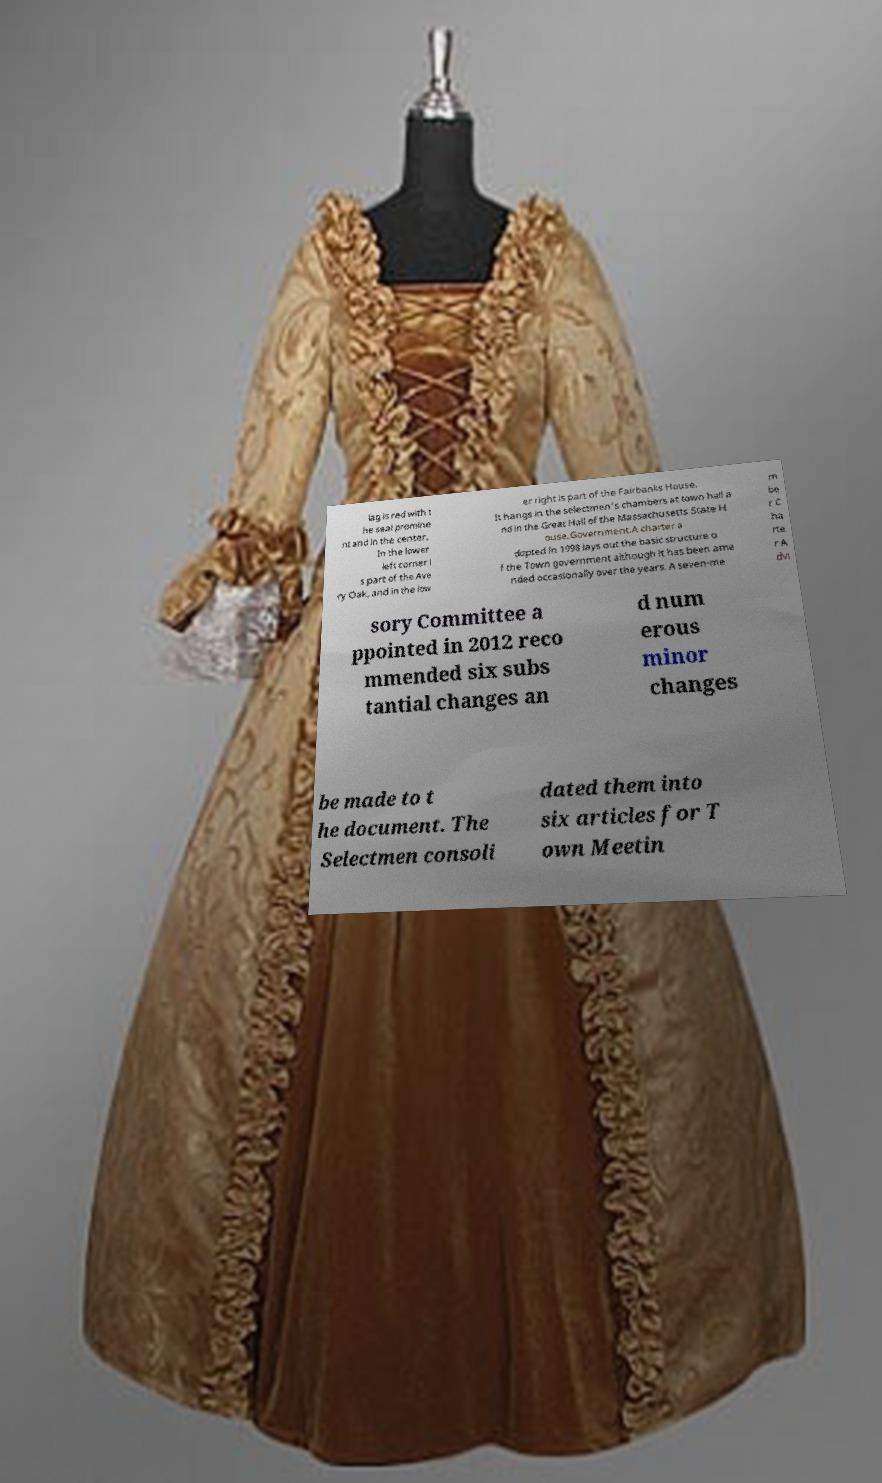For documentation purposes, I need the text within this image transcribed. Could you provide that? lag is red with t he seal promine nt and in the center. In the lower left corner i s part of the Ave ry Oak, and in the low er right is part of the Fairbanks House. It hangs in the selectmen's chambers at town hall a nd in the Great Hall of the Massachusetts State H ouse.Government.A charter a dopted in 1998 lays out the basic structure o f the Town government although it has been ame nded occasionally over the years. A seven-me m be r C ha rte r A dvi sory Committee a ppointed in 2012 reco mmended six subs tantial changes an d num erous minor changes be made to t he document. The Selectmen consoli dated them into six articles for T own Meetin 